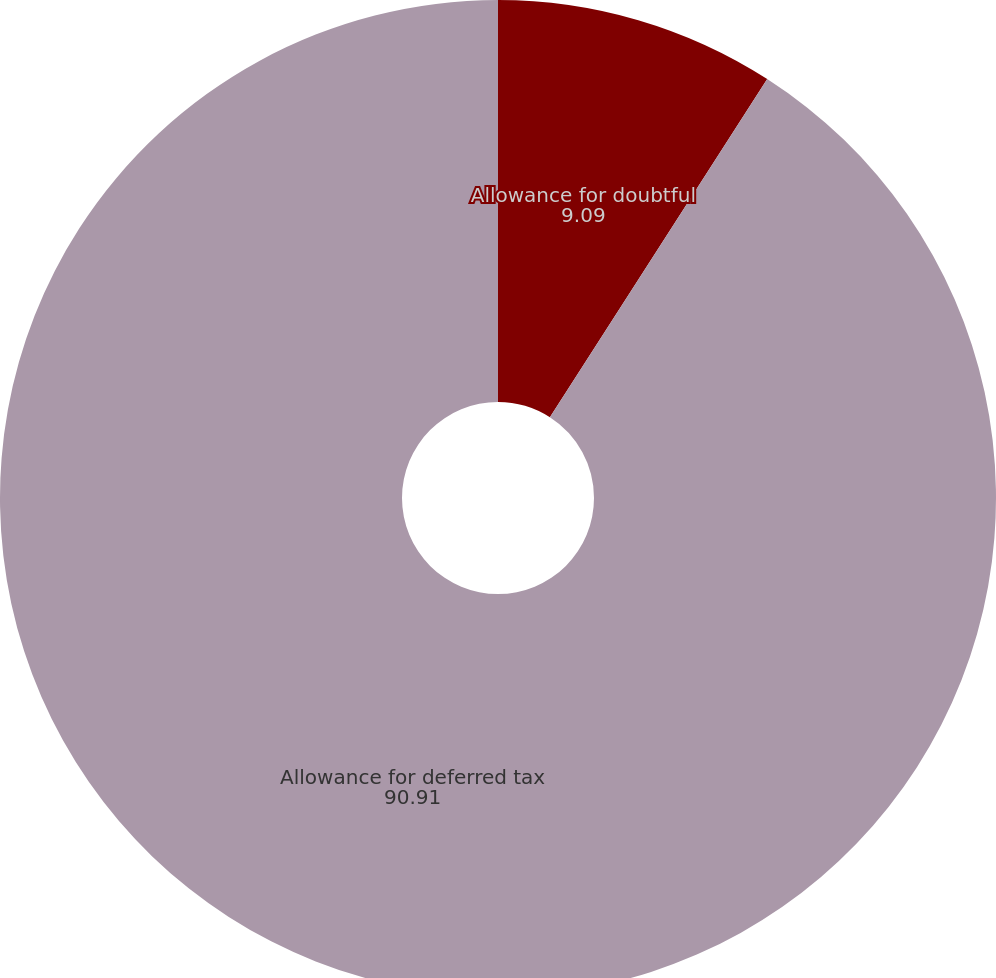Convert chart. <chart><loc_0><loc_0><loc_500><loc_500><pie_chart><fcel>Allowance for doubtful<fcel>Allowance for deferred tax<nl><fcel>9.09%<fcel>90.91%<nl></chart> 